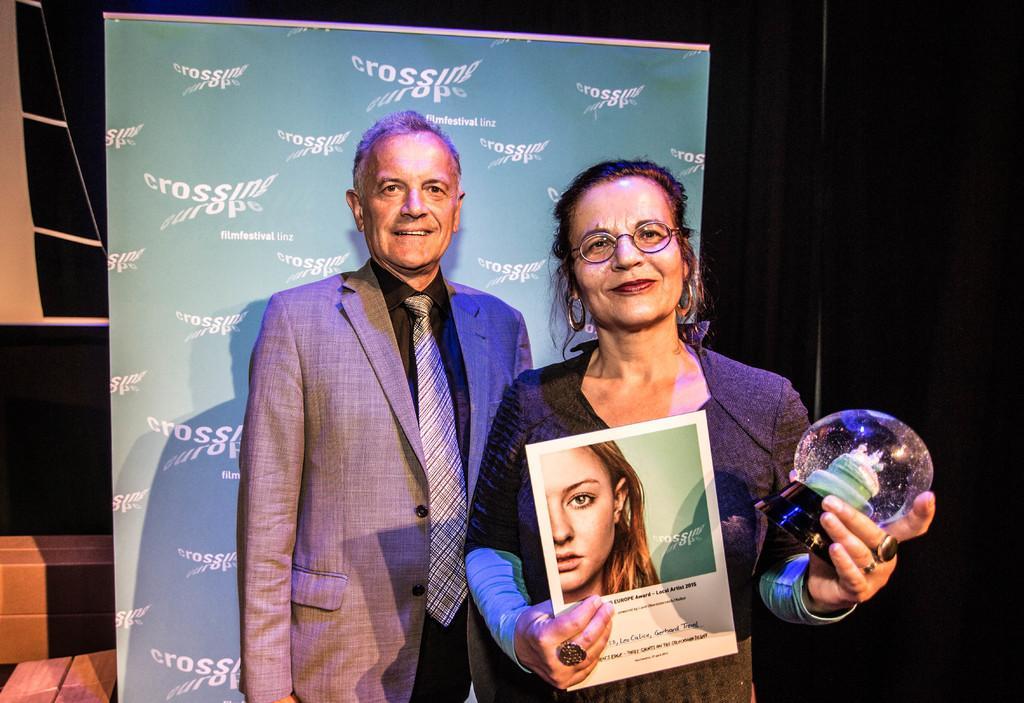In one or two sentences, can you explain what this image depicts? In this image there is one women standing on the right side is holding some objects and the person standing on the left side is wearing a blazer. There is a board in the middle of this image. There is a black color curtain in the background. 